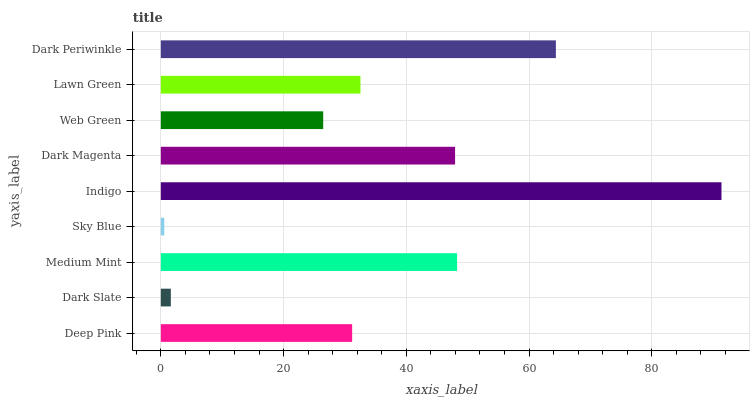Is Sky Blue the minimum?
Answer yes or no. Yes. Is Indigo the maximum?
Answer yes or no. Yes. Is Dark Slate the minimum?
Answer yes or no. No. Is Dark Slate the maximum?
Answer yes or no. No. Is Deep Pink greater than Dark Slate?
Answer yes or no. Yes. Is Dark Slate less than Deep Pink?
Answer yes or no. Yes. Is Dark Slate greater than Deep Pink?
Answer yes or no. No. Is Deep Pink less than Dark Slate?
Answer yes or no. No. Is Lawn Green the high median?
Answer yes or no. Yes. Is Lawn Green the low median?
Answer yes or no. Yes. Is Dark Slate the high median?
Answer yes or no. No. Is Medium Mint the low median?
Answer yes or no. No. 